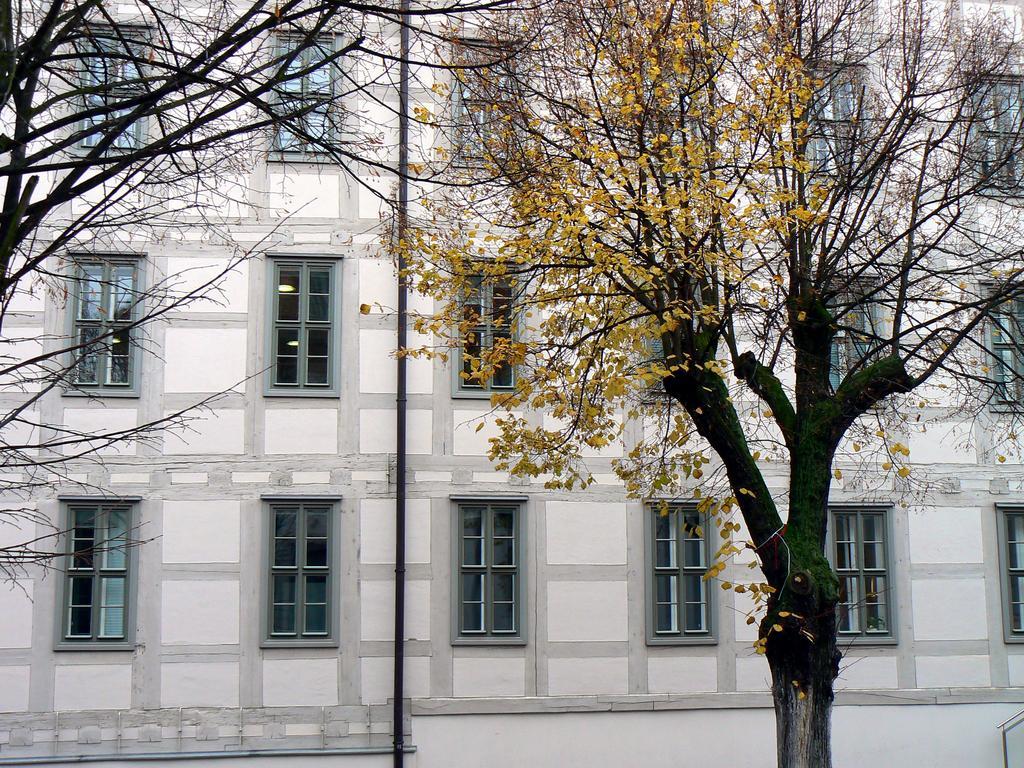In one or two sentences, can you explain what this image depicts? In this picture there is a building. In front of the building I can see the trees. In the center there is a black pole which is placed on the wall near to the windows. 